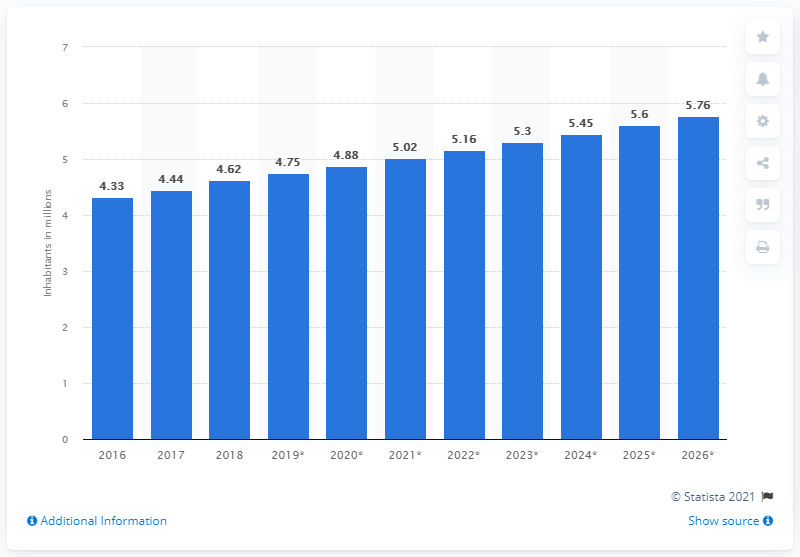What might be some factors contributing to the population growth in Kuwait as shown in the chart? The factors contributing to population growth in Kuwait could include a natural increase due to higher birth rates over death rates, an influx of expatriates due to economic opportunities given the country's oil wealth, and immigration policies that may attract foreign workers to the region. 